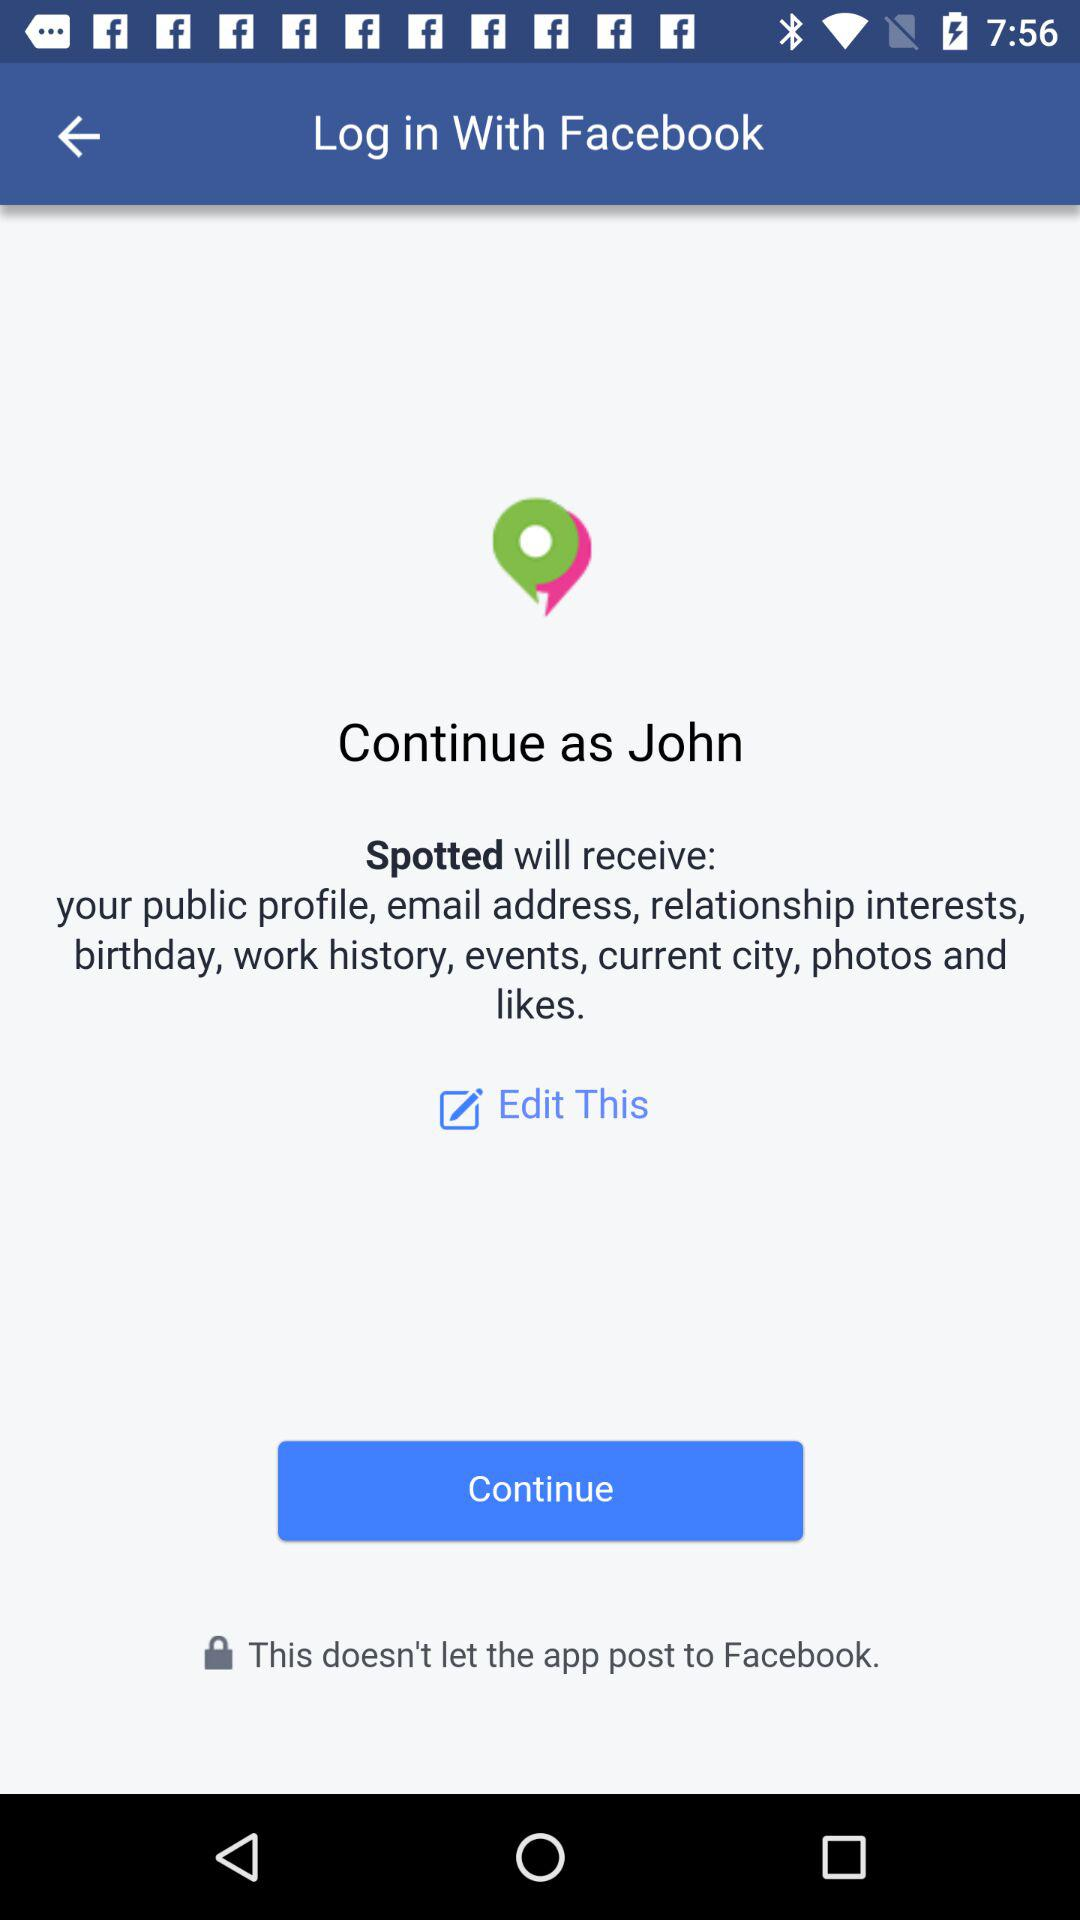Through what application did we log in? You can login with "Facebook". 